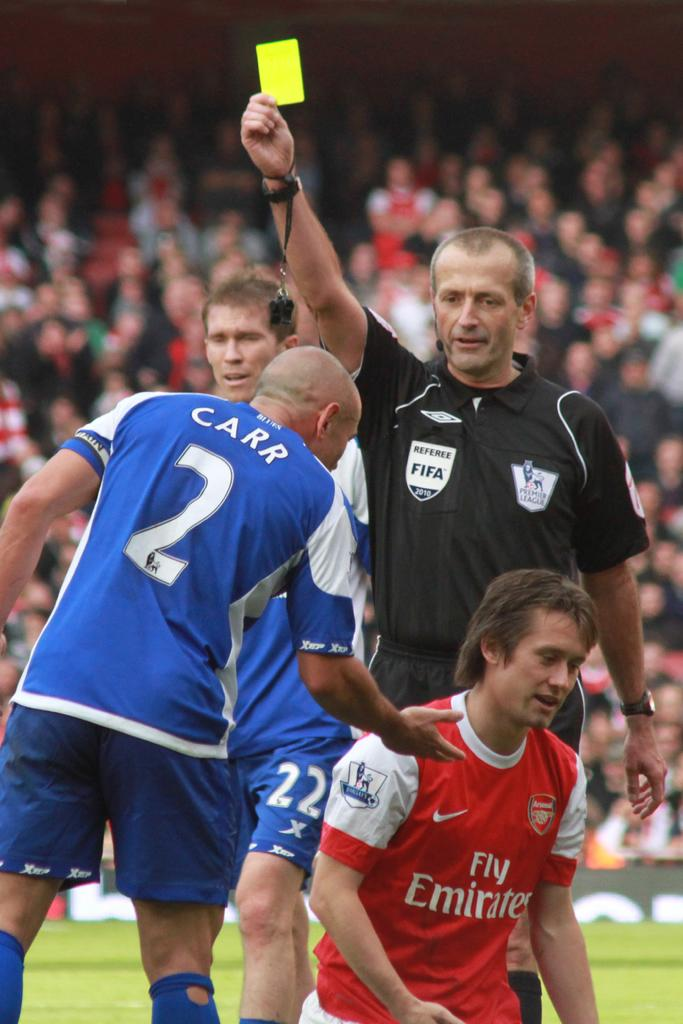<image>
Write a terse but informative summary of the picture. A FIFA referee presents a yellow card to player number 2 who tackled a player in a Fly Emirates jersey. 